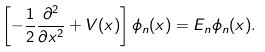<formula> <loc_0><loc_0><loc_500><loc_500>\left [ - \frac { 1 } { 2 } \frac { \partial ^ { 2 } } { \partial x ^ { 2 } } + V ( x ) \right ] \phi _ { n } ( x ) = E _ { n } \phi _ { n } ( x ) .</formula> 